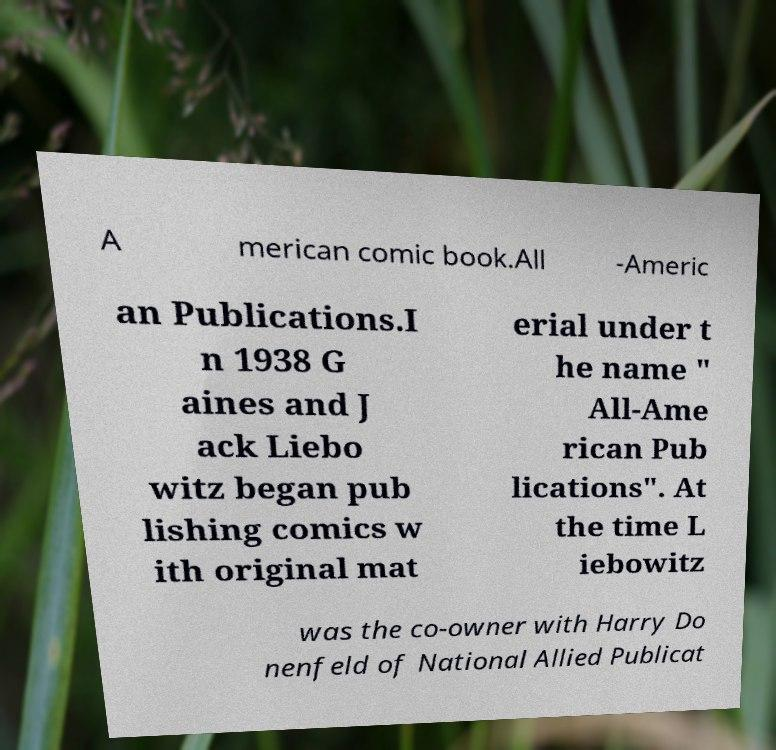What messages or text are displayed in this image? I need them in a readable, typed format. A merican comic book.All -Americ an Publications.I n 1938 G aines and J ack Liebo witz began pub lishing comics w ith original mat erial under t he name " All-Ame rican Pub lications". At the time L iebowitz was the co-owner with Harry Do nenfeld of National Allied Publicat 